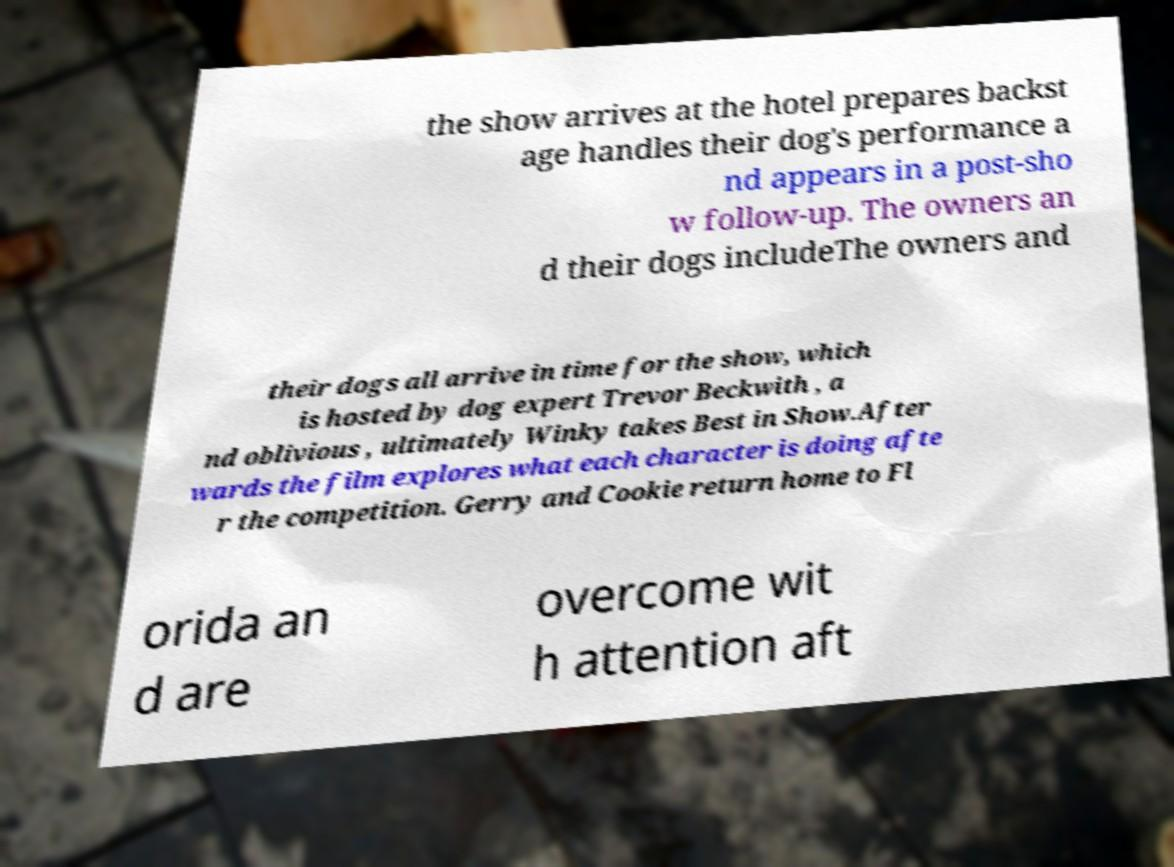Could you assist in decoding the text presented in this image and type it out clearly? the show arrives at the hotel prepares backst age handles their dog's performance a nd appears in a post-sho w follow-up. The owners an d their dogs includeThe owners and their dogs all arrive in time for the show, which is hosted by dog expert Trevor Beckwith , a nd oblivious , ultimately Winky takes Best in Show.After wards the film explores what each character is doing afte r the competition. Gerry and Cookie return home to Fl orida an d are overcome wit h attention aft 